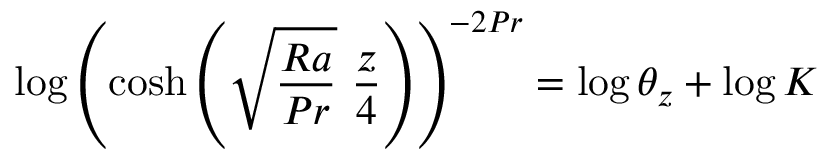Convert formula to latex. <formula><loc_0><loc_0><loc_500><loc_500>\log { \left ( \cosh { \left ( \sqrt { \frac { R a } { P r } } \ \frac { z } { 4 } \right ) } \right ) ^ { - 2 P r } } = \log { \theta _ { z } } + \log K</formula> 